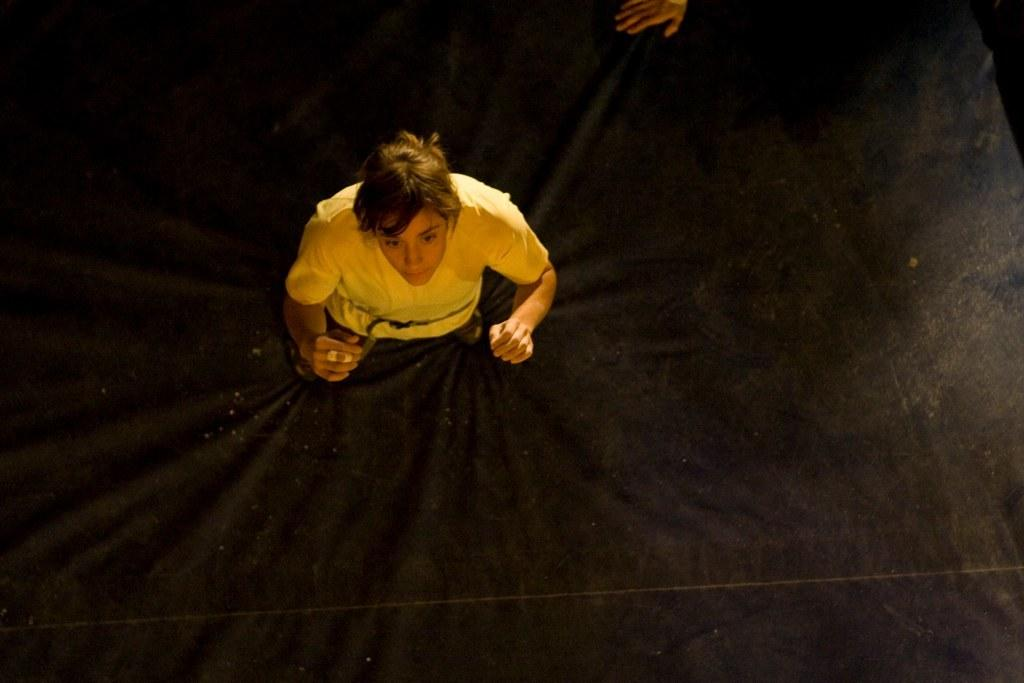Who or what is present in the image? There is a person in the image. What else can be seen in the image besides the person? There is cloth in the image. Can you describe any specific body part of the person in the image? A person's hand is visible in the image. What might be the time of day when the image was taken? The image may have been taken during the night. How does the person in the image cry for help? There is no indication in the image that the person is crying for help or that any crying is taking place. 